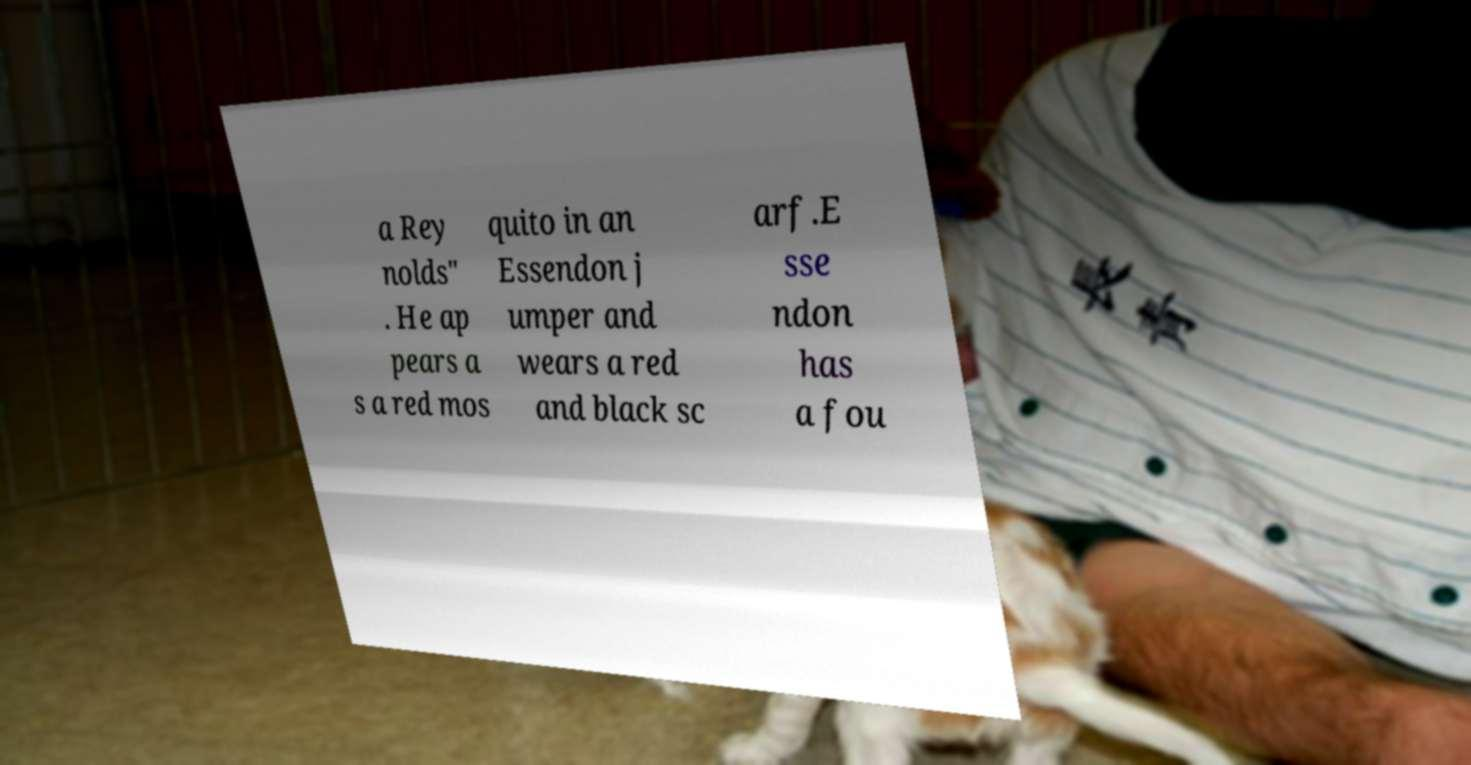Please identify and transcribe the text found in this image. a Rey nolds" . He ap pears a s a red mos quito in an Essendon j umper and wears a red and black sc arf.E sse ndon has a fou 